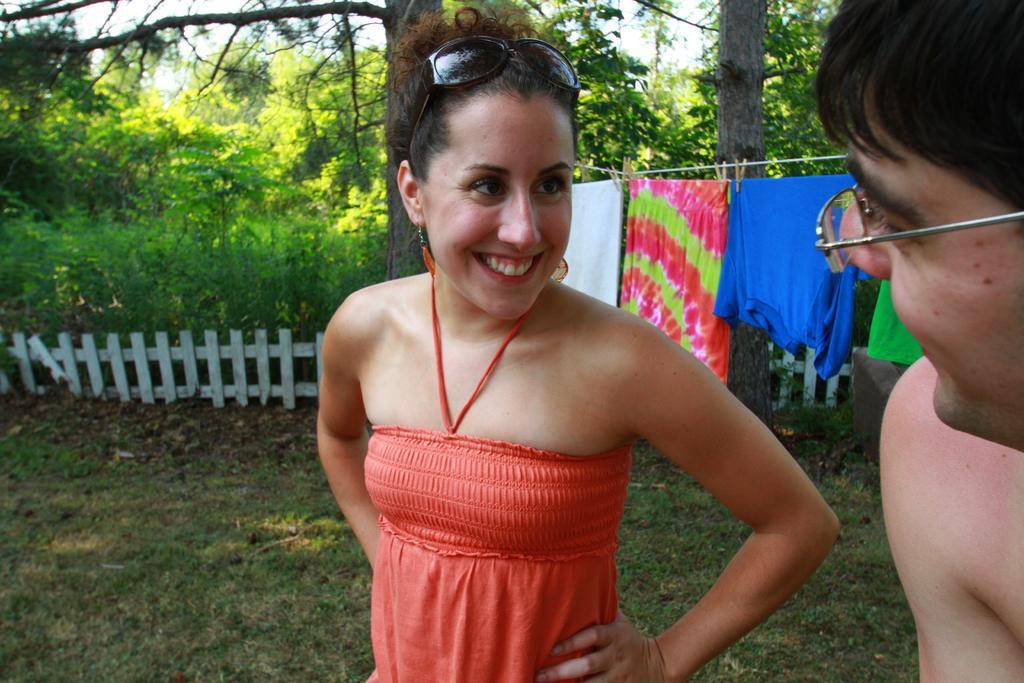Describe this image in one or two sentences. On the right side of the image there is a man with spectacles. And there is a lady standing and she is smiling. On her head there are goggles. Behind them there are clothes hanging on the rope. In the background there are trees and also there is a fencing. On the ground there is grass. 